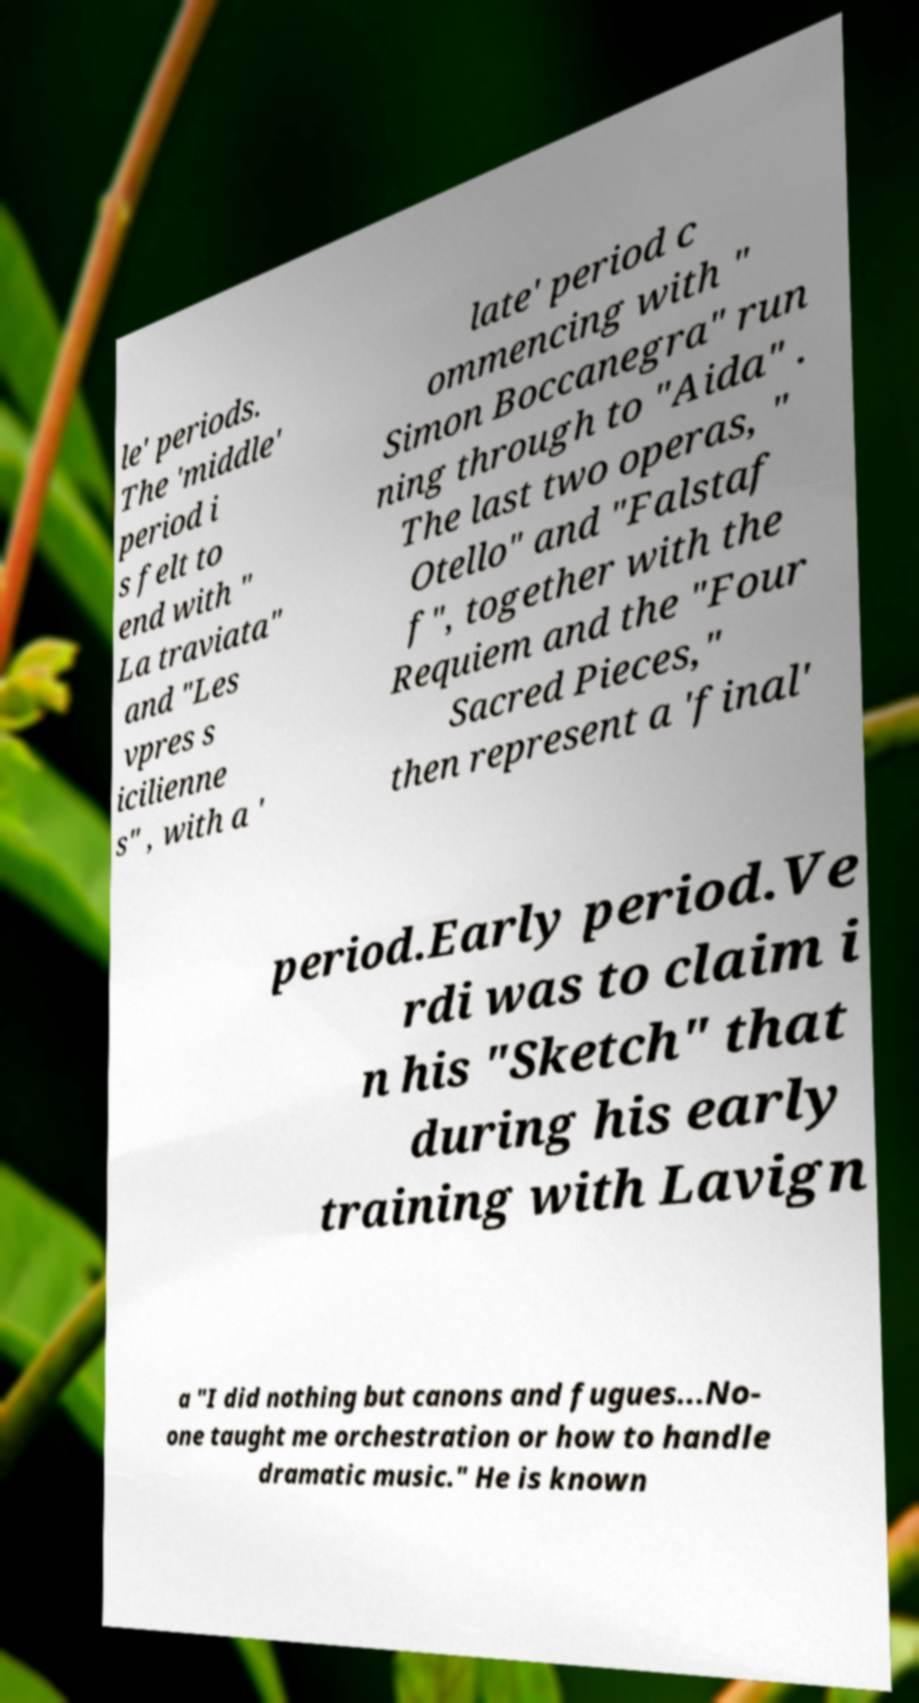Can you accurately transcribe the text from the provided image for me? le' periods. The 'middle' period i s felt to end with " La traviata" and "Les vpres s icilienne s" , with a ' late' period c ommencing with " Simon Boccanegra" run ning through to "Aida" . The last two operas, " Otello" and "Falstaf f", together with the Requiem and the "Four Sacred Pieces," then represent a 'final' period.Early period.Ve rdi was to claim i n his "Sketch" that during his early training with Lavign a "I did nothing but canons and fugues...No- one taught me orchestration or how to handle dramatic music." He is known 